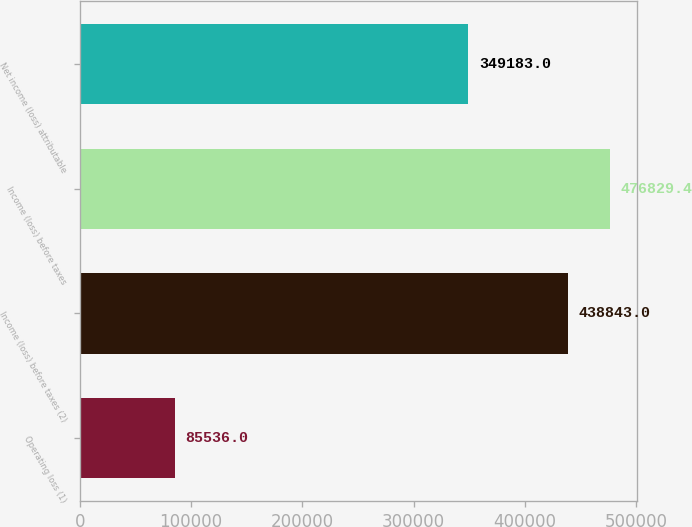<chart> <loc_0><loc_0><loc_500><loc_500><bar_chart><fcel>Operating loss (1)<fcel>Income (loss) before taxes (2)<fcel>Income (loss) before taxes<fcel>Net income (loss) attributable<nl><fcel>85536<fcel>438843<fcel>476829<fcel>349183<nl></chart> 